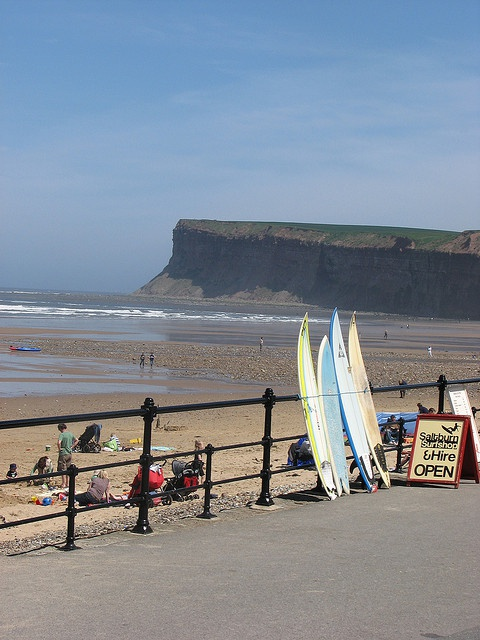Describe the objects in this image and their specific colors. I can see surfboard in gray, white, darkgray, and lightblue tones, surfboard in gray, ivory, yellow, khaki, and darkgray tones, surfboard in gray, lightblue, lightgray, beige, and darkgray tones, surfboard in gray, tan, and beige tones, and people in gray, black, and darkgray tones in this image. 